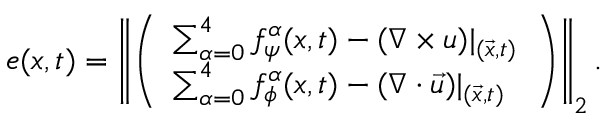<formula> <loc_0><loc_0><loc_500><loc_500>e ( x , t ) = \left \| \left ( \begin{array} { l } { \sum _ { \alpha = 0 } ^ { 4 } f _ { \psi } ^ { \alpha } ( x , t ) - ( \nabla \times u ) | _ { ( \vec { x } , t ) } } \\ { \sum _ { \alpha = 0 } ^ { 4 } f _ { \phi } ^ { \alpha } ( x , t ) - ( \nabla \cdot { \vec { u } } ) | _ { ( \vec { x } , t ) } } \end{array} \right ) \right \| _ { 2 } .</formula> 